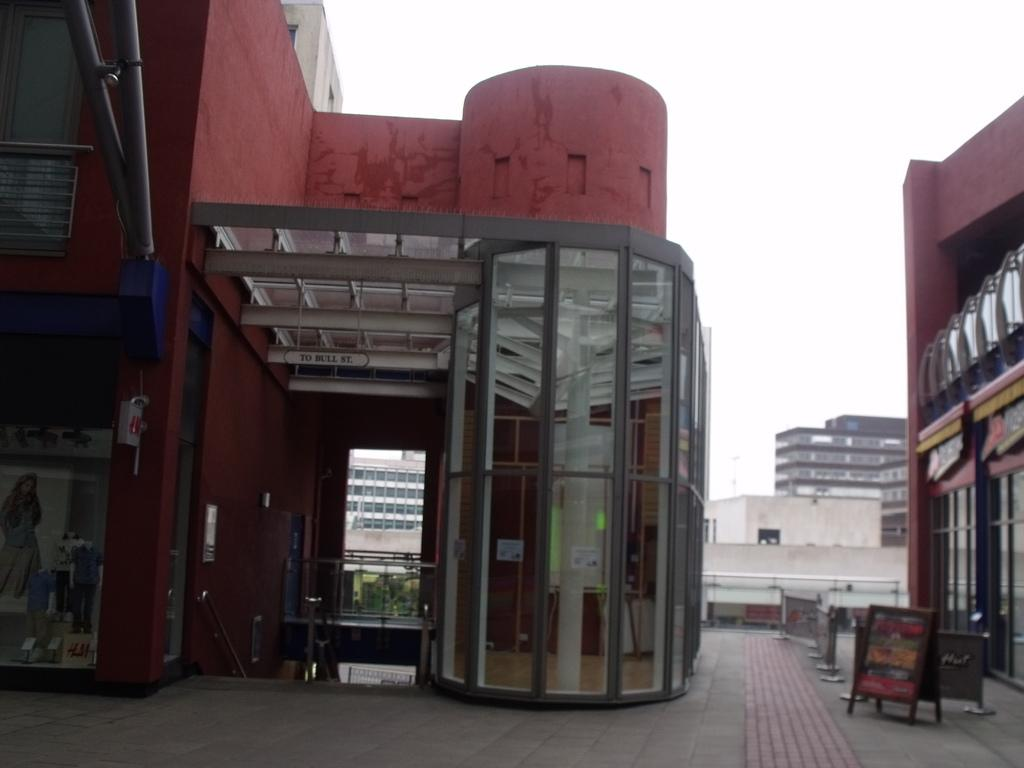What type of structures can be seen in the image? There are buildings in the image. What else can be seen in the image besides buildings? There are boards, fencing, trees, an advertisement, and pipes visible in the image. What is the background of the image? The sky is visible in the image. How does the store provide comfort to customers in the image? There is no store present in the image, so it cannot provide comfort to customers. 